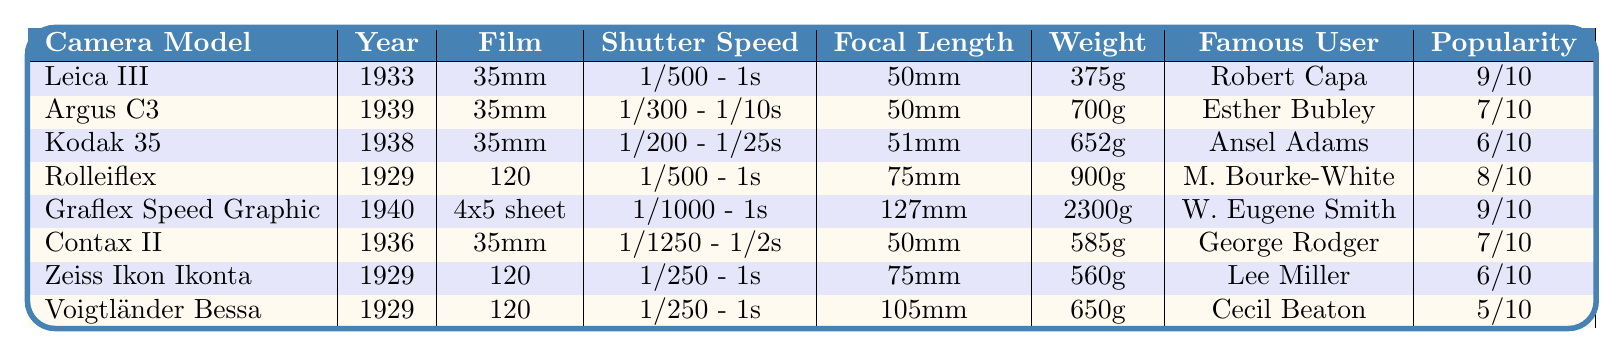What is the camera model with the highest popularity rating among WWII photographers? The popularity ratings are listed in the column for "Popularity Among WWII Photographers." The highest rating is 9, which is associated with the Leica III and Graflex Speed Graphic.
Answer: Leica III and Graflex Speed Graphic Which camera was introduced first? We can look at the "Year Introduced" column to identify the earliest year. The Rolleiflex is listed as being introduced in 1929, which is the earliest date among all the cameras.
Answer: Rolleiflex What type of film does the Graflex Speed Graphic use? The film type is specified in the "Film Type" column. For the Graflex Speed Graphic, it states "4x5 sheet."
Answer: 4x5 sheet How much does the Argus C3 weigh compared to the Zeppelin III? We compare the weights provided for each camera. The Argus C3 weighs 700 grams, while the weight of the Zeppelin III is not mentioned. Therefore, we cannot make a comparison.
Answer: Comparison not possible Which camera model has the longest shutter speed range? The "Shutter Speed Range" column shows that both the Leica III and Rolleiflex have the shutter speed range of 1/500 - 1s, which are the longest speed ranges listed.
Answer: Leica III and Rolleiflex Is there any camera that Ansel Adams used? We check the "Used by Famous WWII Photographer" column to see if Ansel Adams is listed. He is indeed associated with the Kodak 35.
Answer: Yes Which camera models use 120 film? The "Film Type" column shows that the Rolleiflex, Zeiss Ikon Ikonta, and Voigtländer Bessa use 120 film.
Answer: Rolleiflex, Zeiss Ikon Ikonta, Voigtländer Bessa What is the average weight of the cameras listed? We sum the weights of all cameras: (375 + 700 + 652 + 900 + 2300 + 585 + 560 + 650) = 6172 grams. There are 8 cameras, so the average weight is 6172 / 8 = 771.5 grams.
Answer: 771.5 grams Which camera has the same lens focal length as the Kodak 35? We find the lens focal length of the Kodak 35 in the "Lens Focal Length (mm)" column, which is 51mm. The Argus C3 also has a 50mm focal length, which is the closest match.
Answer: No exact match Which famous photographers used cameras with a popularity rating of 6? We look at the "Popularity Among WWII Photographers" column and find the Kodak 35 and Zeiss Ikon Ikonta both have a rating of 6. The photographers associated are Ansel Adams and Lee Miller, respectively.
Answer: Ansel Adams and Lee Miller 